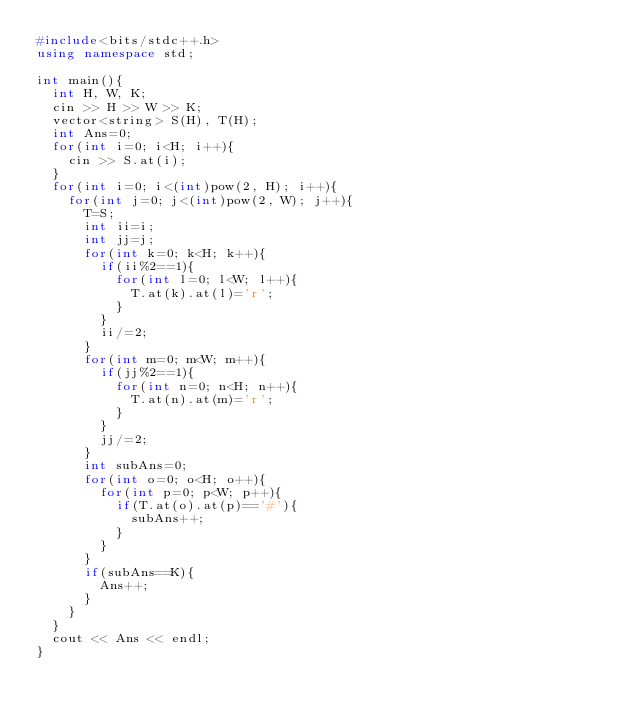Convert code to text. <code><loc_0><loc_0><loc_500><loc_500><_C++_>#include<bits/stdc++.h>
using namespace std;

int main(){
  int H, W, K;
  cin >> H >> W >> K;
  vector<string> S(H), T(H);
  int Ans=0;
  for(int i=0; i<H; i++){
    cin >> S.at(i);
  }
  for(int i=0; i<(int)pow(2, H); i++){
    for(int j=0; j<(int)pow(2, W); j++){
      T=S;
      int ii=i;
      int jj=j;
      for(int k=0; k<H; k++){
        if(ii%2==1){
          for(int l=0; l<W; l++){
            T.at(k).at(l)='r';
          }
        }
        ii/=2;
      }
      for(int m=0; m<W; m++){
        if(jj%2==1){
          for(int n=0; n<H; n++){
            T.at(n).at(m)='r';
          }
        }
        jj/=2;
      }
      int subAns=0;
      for(int o=0; o<H; o++){
        for(int p=0; p<W; p++){
          if(T.at(o).at(p)=='#'){
            subAns++;
          }
        }
      }
      if(subAns==K){
        Ans++;
      }
    }
  }
  cout << Ans << endl;
}</code> 